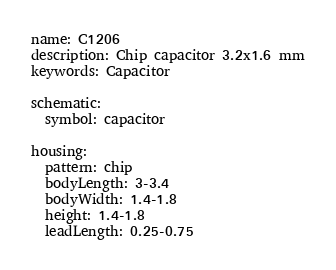Convert code to text. <code><loc_0><loc_0><loc_500><loc_500><_YAML_>name: C1206
description: Chip capacitor 3.2x1.6 mm
keywords: Capacitor

schematic:
  symbol: capacitor

housing:
  pattern: chip
  bodyLength: 3-3.4
  bodyWidth: 1.4-1.8
  height: 1.4-1.8
  leadLength: 0.25-0.75
</code> 